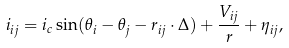Convert formula to latex. <formula><loc_0><loc_0><loc_500><loc_500>i _ { i j } = i _ { c } \sin ( \theta _ { i } - \theta _ { j } - { r } _ { i j } \cdot { \Delta } ) + \frac { V _ { i j } } { r } + \eta _ { i j } ,</formula> 